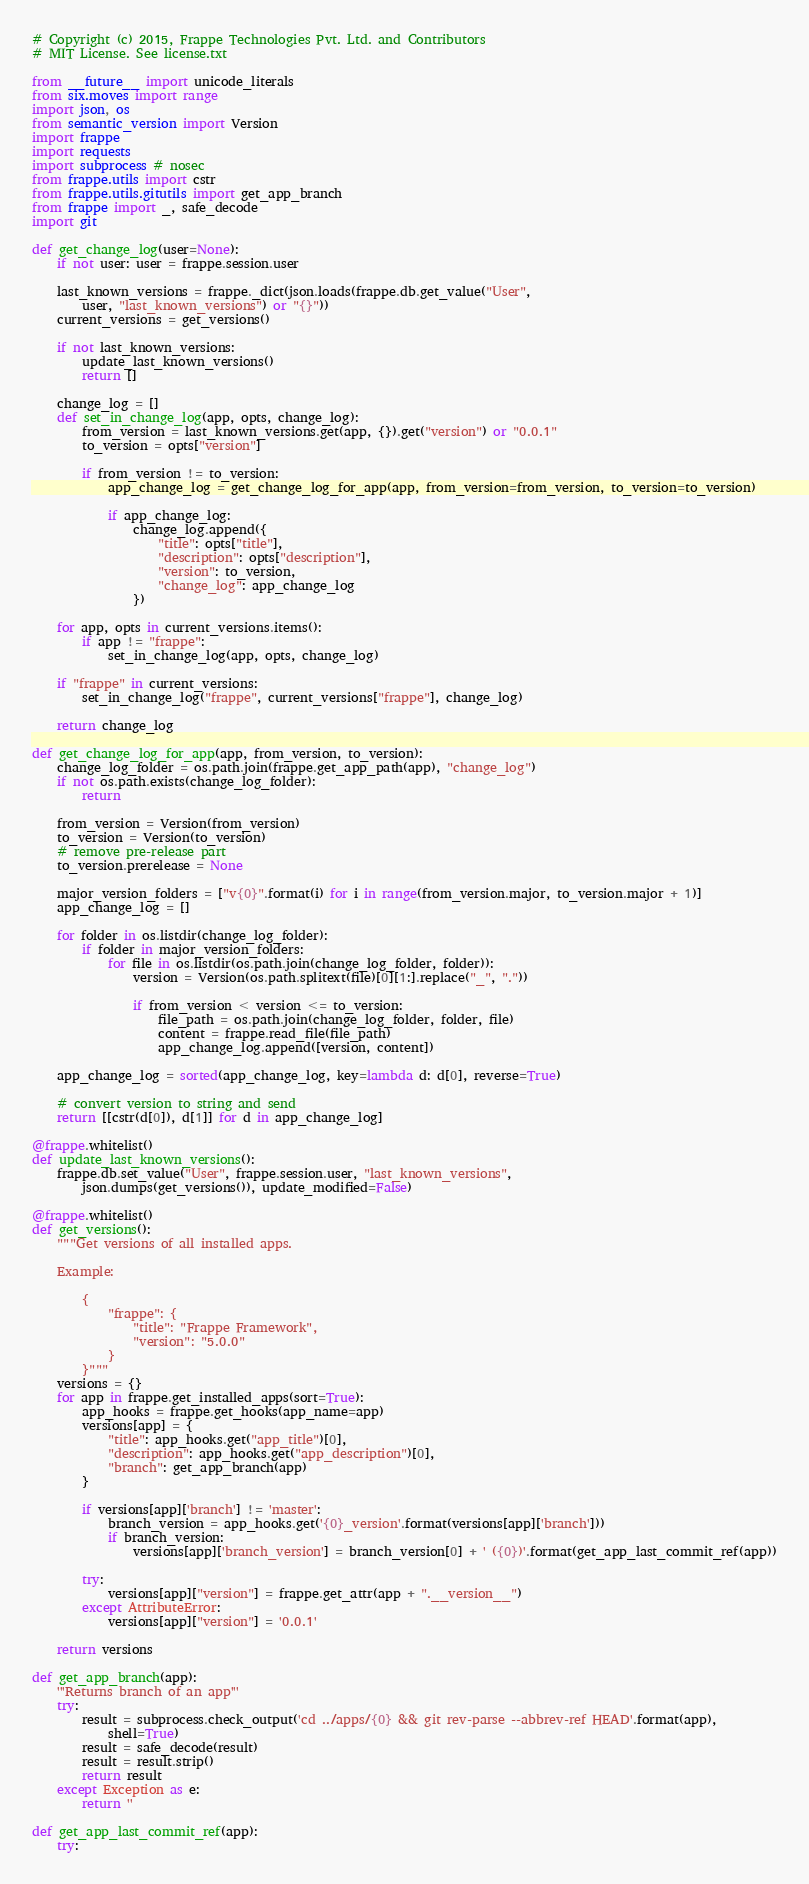Convert code to text. <code><loc_0><loc_0><loc_500><loc_500><_Python_># Copyright (c) 2015, Frappe Technologies Pvt. Ltd. and Contributors
# MIT License. See license.txt

from __future__ import unicode_literals
from six.moves import range
import json, os
from semantic_version import Version
import frappe
import requests
import subprocess # nosec
from frappe.utils import cstr
from frappe.utils.gitutils import get_app_branch
from frappe import _, safe_decode
import git

def get_change_log(user=None):
	if not user: user = frappe.session.user

	last_known_versions = frappe._dict(json.loads(frappe.db.get_value("User",
		user, "last_known_versions") or "{}"))
	current_versions = get_versions()

	if not last_known_versions:
		update_last_known_versions()
		return []

	change_log = []
	def set_in_change_log(app, opts, change_log):
		from_version = last_known_versions.get(app, {}).get("version") or "0.0.1"
		to_version = opts["version"]

		if from_version != to_version:
			app_change_log = get_change_log_for_app(app, from_version=from_version, to_version=to_version)

			if app_change_log:
				change_log.append({
					"title": opts["title"],
					"description": opts["description"],
					"version": to_version,
					"change_log": app_change_log
				})

	for app, opts in current_versions.items():
		if app != "frappe":
			set_in_change_log(app, opts, change_log)

	if "frappe" in current_versions:
		set_in_change_log("frappe", current_versions["frappe"], change_log)

	return change_log

def get_change_log_for_app(app, from_version, to_version):
	change_log_folder = os.path.join(frappe.get_app_path(app), "change_log")
	if not os.path.exists(change_log_folder):
		return

	from_version = Version(from_version)
	to_version = Version(to_version)
	# remove pre-release part
	to_version.prerelease = None

	major_version_folders = ["v{0}".format(i) for i in range(from_version.major, to_version.major + 1)]
	app_change_log = []

	for folder in os.listdir(change_log_folder):
		if folder in major_version_folders:
			for file in os.listdir(os.path.join(change_log_folder, folder)):
				version = Version(os.path.splitext(file)[0][1:].replace("_", "."))

				if from_version < version <= to_version:
					file_path = os.path.join(change_log_folder, folder, file)
					content = frappe.read_file(file_path)
					app_change_log.append([version, content])

	app_change_log = sorted(app_change_log, key=lambda d: d[0], reverse=True)

	# convert version to string and send
	return [[cstr(d[0]), d[1]] for d in app_change_log]

@frappe.whitelist()
def update_last_known_versions():
	frappe.db.set_value("User", frappe.session.user, "last_known_versions",
		json.dumps(get_versions()), update_modified=False)

@frappe.whitelist()
def get_versions():
	"""Get versions of all installed apps.

	Example:

		{
			"frappe": {
				"title": "Frappe Framework",
				"version": "5.0.0"
			}
		}"""
	versions = {}
	for app in frappe.get_installed_apps(sort=True):
		app_hooks = frappe.get_hooks(app_name=app)
		versions[app] = {
			"title": app_hooks.get("app_title")[0],
			"description": app_hooks.get("app_description")[0],
			"branch": get_app_branch(app)
		}

		if versions[app]['branch'] != 'master':
			branch_version = app_hooks.get('{0}_version'.format(versions[app]['branch']))
			if branch_version:
				versions[app]['branch_version'] = branch_version[0] + ' ({0})'.format(get_app_last_commit_ref(app))

		try:
			versions[app]["version"] = frappe.get_attr(app + ".__version__")
		except AttributeError:
			versions[app]["version"] = '0.0.1'

	return versions

def get_app_branch(app):
	'''Returns branch of an app'''
	try:
		result = subprocess.check_output('cd ../apps/{0} && git rev-parse --abbrev-ref HEAD'.format(app),
			shell=True)
		result = safe_decode(result)
		result = result.strip()
		return result
	except Exception as e:
		return ''

def get_app_last_commit_ref(app):
	try:</code> 